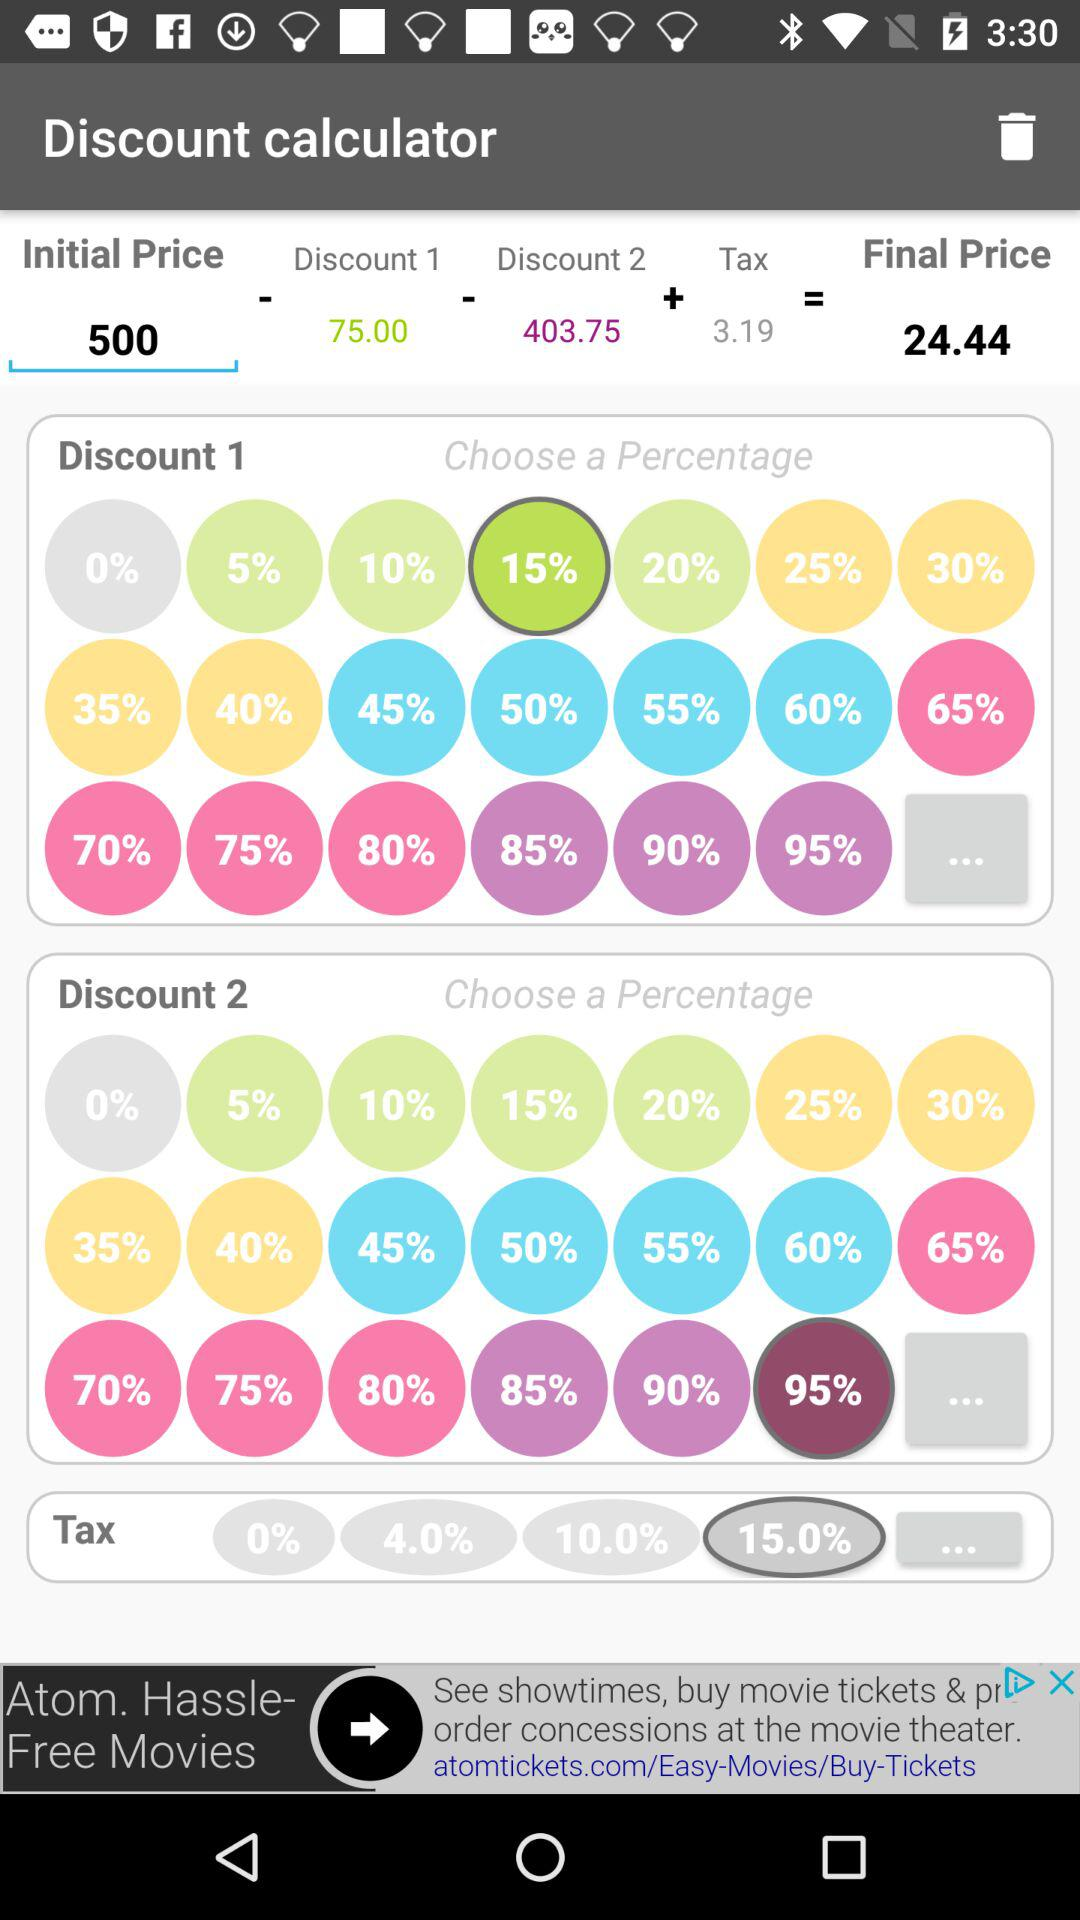What's the initial price? The initial price is 500. 